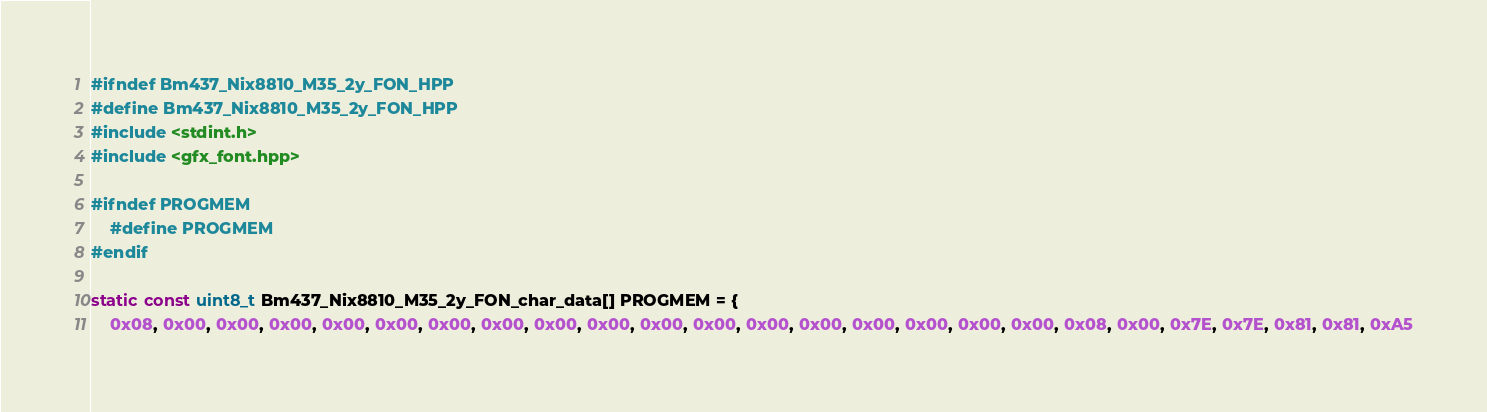<code> <loc_0><loc_0><loc_500><loc_500><_C_>#ifndef Bm437_Nix8810_M35_2y_FON_HPP
#define Bm437_Nix8810_M35_2y_FON_HPP
#include <stdint.h>
#include <gfx_font.hpp>

#ifndef PROGMEM
	#define PROGMEM
#endif

static const uint8_t Bm437_Nix8810_M35_2y_FON_char_data[] PROGMEM = {
	0x08, 0x00, 0x00, 0x00, 0x00, 0x00, 0x00, 0x00, 0x00, 0x00, 0x00, 0x00, 0x00, 0x00, 0x00, 0x00, 0x00, 0x00, 0x08, 0x00, 0x7E, 0x7E, 0x81, 0x81, 0xA5</code> 